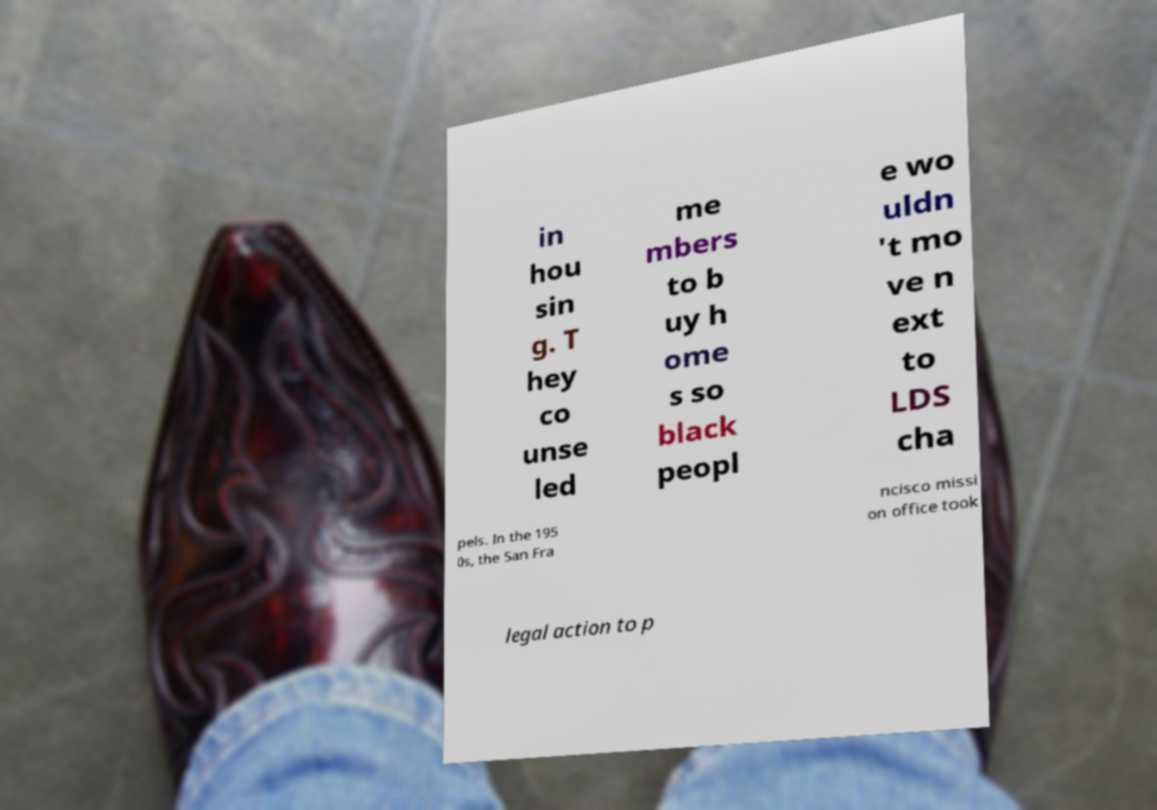I need the written content from this picture converted into text. Can you do that? in hou sin g. T hey co unse led me mbers to b uy h ome s so black peopl e wo uldn 't mo ve n ext to LDS cha pels. In the 195 0s, the San Fra ncisco missi on office took legal action to p 